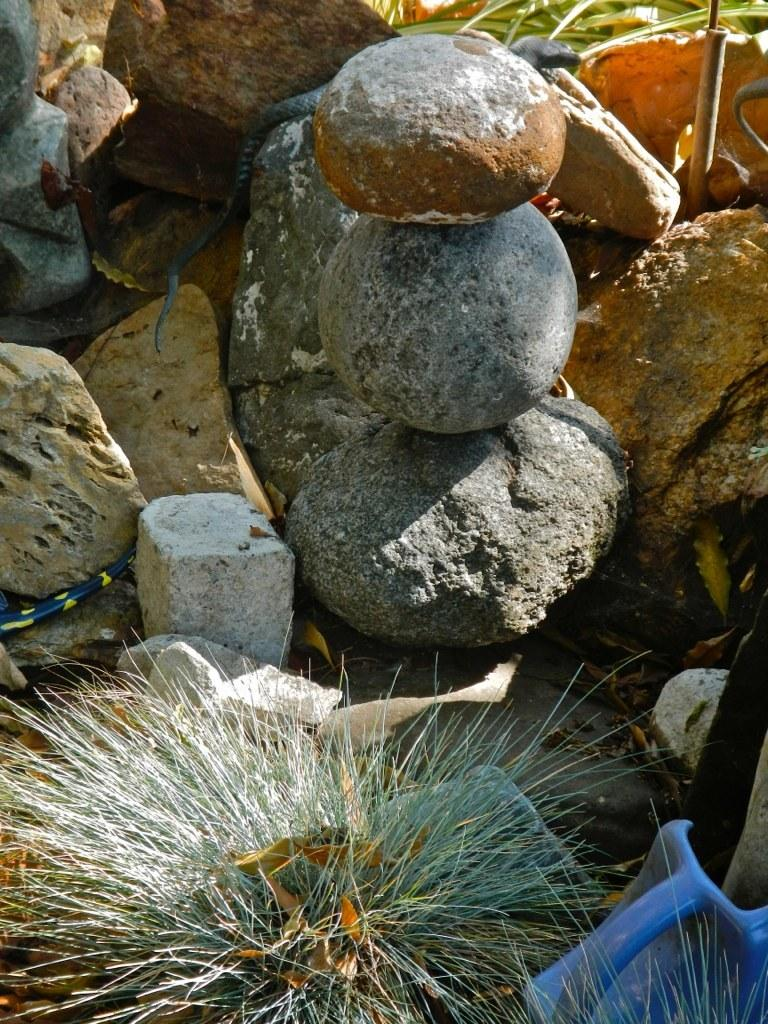What type of objects are on the ground in the image? There are stones on the ground in the image. What other element can be seen in the image besides the stones? There is a plant visible in the image. How many jellyfish are swimming in the image? There are no jellyfish present in the image; it features stones on the ground and a plant. What type of letters can be seen on the plant in the image? There are no letters visible on the plant in the image; it is a plant without any text or writing. 